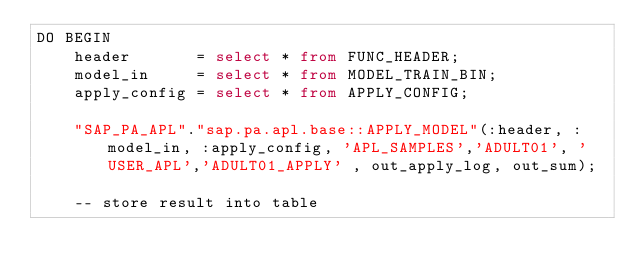Convert code to text. <code><loc_0><loc_0><loc_500><loc_500><_SQL_>DO BEGIN     
    header       = select * from FUNC_HEADER;             
    model_in     = select * from MODEL_TRAIN_BIN; 	           
    apply_config = select * from APPLY_CONFIG; 	           

    "SAP_PA_APL"."sap.pa.apl.base::APPLY_MODEL"(:header, :model_in, :apply_config, 'APL_SAMPLES','ADULT01', 'USER_APL','ADULT01_APPLY' , out_apply_log, out_sum);

    -- store result into table</code> 